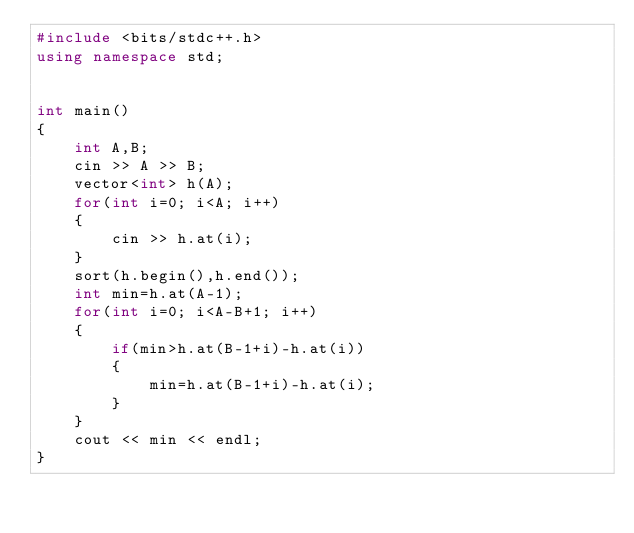Convert code to text. <code><loc_0><loc_0><loc_500><loc_500><_C++_>#include <bits/stdc++.h>
using namespace std;


int main()
{
    int A,B;
    cin >> A >> B;
    vector<int> h(A);
    for(int i=0; i<A; i++)
    {
        cin >> h.at(i);
    }
    sort(h.begin(),h.end());
    int min=h.at(A-1);
    for(int i=0; i<A-B+1; i++)
    {
        if(min>h.at(B-1+i)-h.at(i))
        {
            min=h.at(B-1+i)-h.at(i);
        }
    }
    cout << min << endl;
}
</code> 